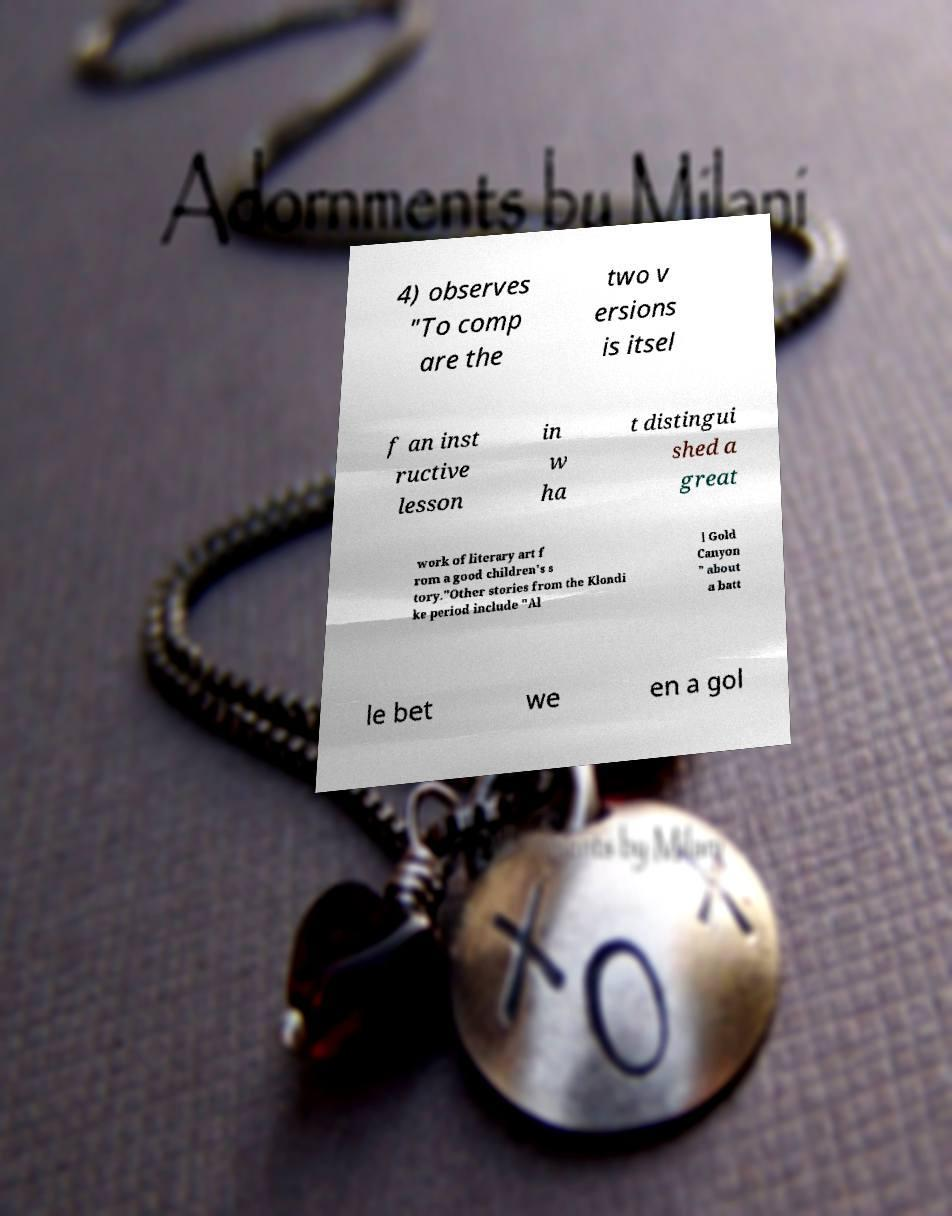There's text embedded in this image that I need extracted. Can you transcribe it verbatim? 4) observes "To comp are the two v ersions is itsel f an inst ructive lesson in w ha t distingui shed a great work of literary art f rom a good children's s tory."Other stories from the Klondi ke period include "Al l Gold Canyon " about a batt le bet we en a gol 